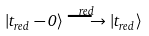<formula> <loc_0><loc_0><loc_500><loc_500>| t _ { r e d } - 0 \rangle \stackrel { r e d } \longrightarrow | t _ { r e d } \rangle</formula> 